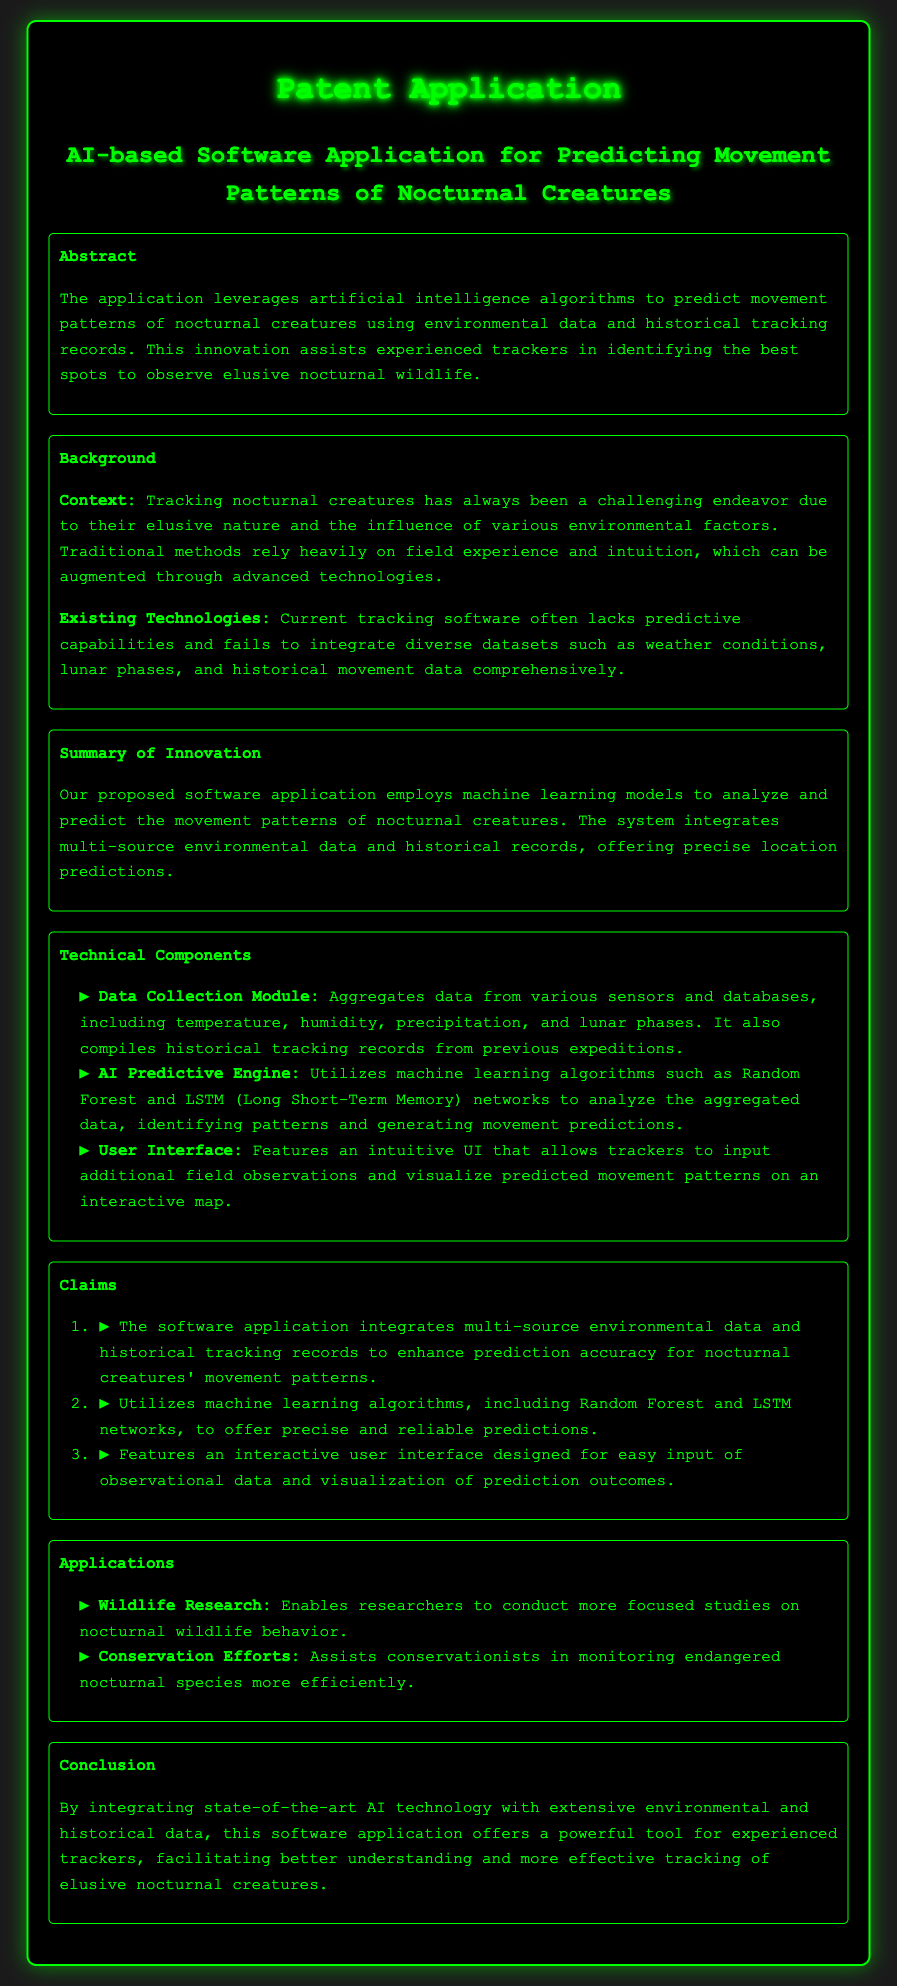what is the title of the patent application? The title is the main heading of the document, which states the focus of the innovation.
Answer: AI-based Software Application for Predicting Movement Patterns of Nocturnal Creatures what algorithms does the AI Predictive Engine utilize? The document lists the specific machine learning algorithms used in the software application for predictions.
Answer: Random Forest and LSTM networks what is the main purpose of the software application? The abstract of the document outlines the primary goal of the application.
Answer: Predicting movement patterns of nocturnal creatures how does the software enhance prediction accuracy? The claims section explains the functionality of the software, which includes integrating multiple data sources for improved predictions.
Answer: Integrates multi-source environmental data and historical tracking records which environmental factors are included in the Data Collection Module? The document specifies what type of environmental data is collected in the module used by the software.
Answer: Temperature, humidity, precipitation, and lunar phases which sections of the patent application are present in the document? The structure of the patent application outlines the main components and their sequence.
Answer: Abstract, Background, Summary of Innovation, Technical Components, Claims, Applications, Conclusion what is one application of this software in conservation efforts? The Applications section describes how the software can be utilized in the context of conservation.
Answer: Monitoring endangered nocturnal species more efficiently what problem does this innovation aim to address? The Background section details the challenges faced in tracking nocturnal creatures which the software seeks to mitigate.
Answer: Elusive nature of nocturnal creatures and environmental factors 